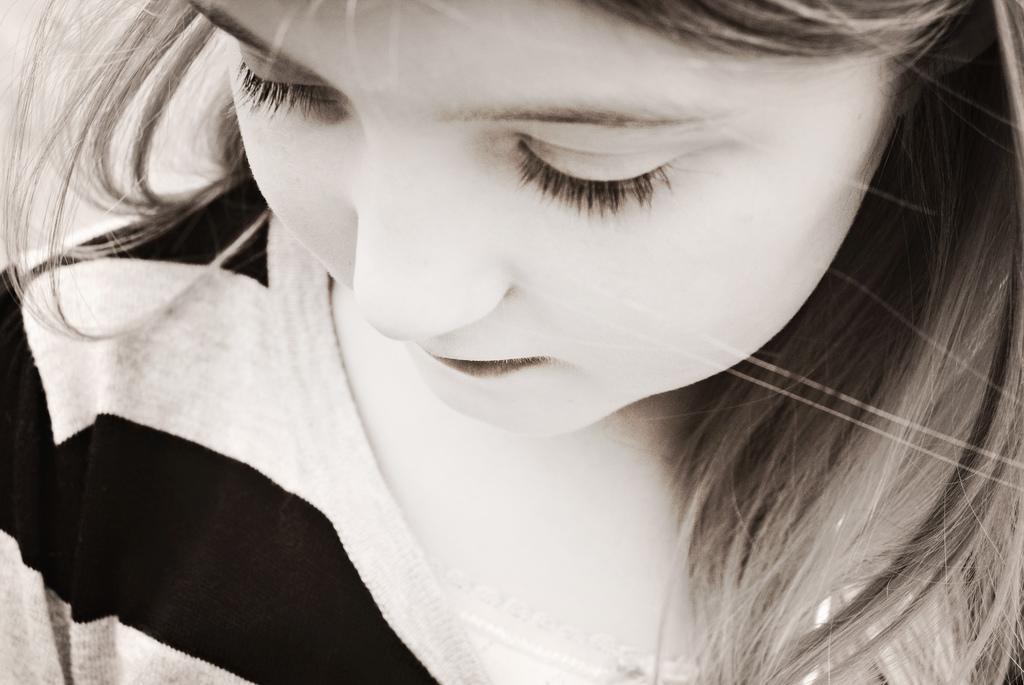Describe this image in one or two sentences. It is a black and white image and also a zoomed picture of a girl. 